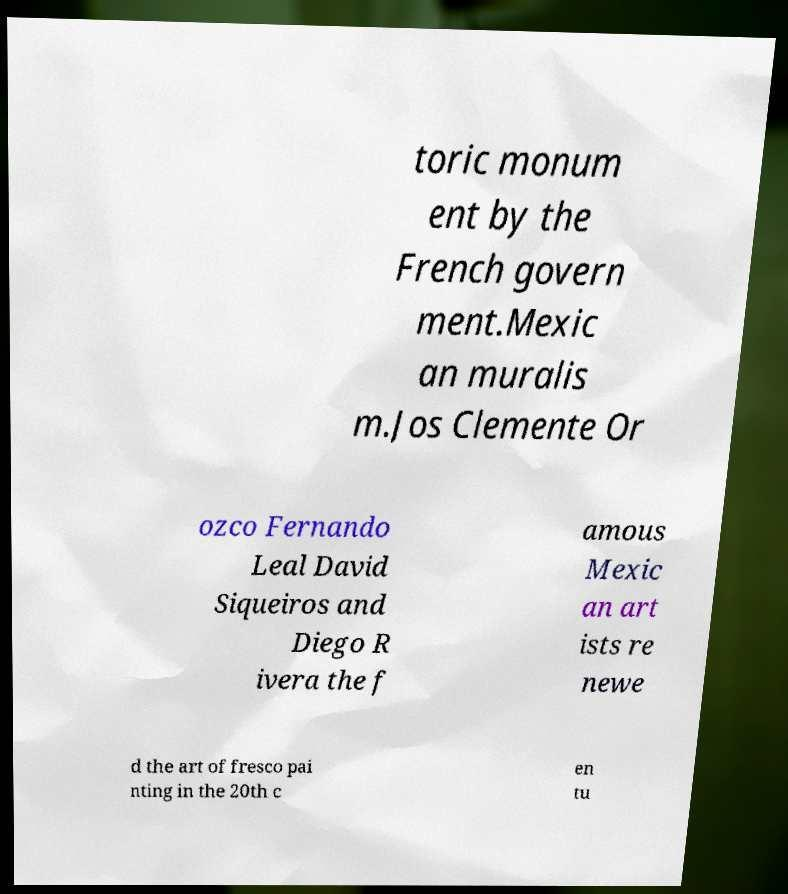Please read and relay the text visible in this image. What does it say? toric monum ent by the French govern ment.Mexic an muralis m.Jos Clemente Or ozco Fernando Leal David Siqueiros and Diego R ivera the f amous Mexic an art ists re newe d the art of fresco pai nting in the 20th c en tu 